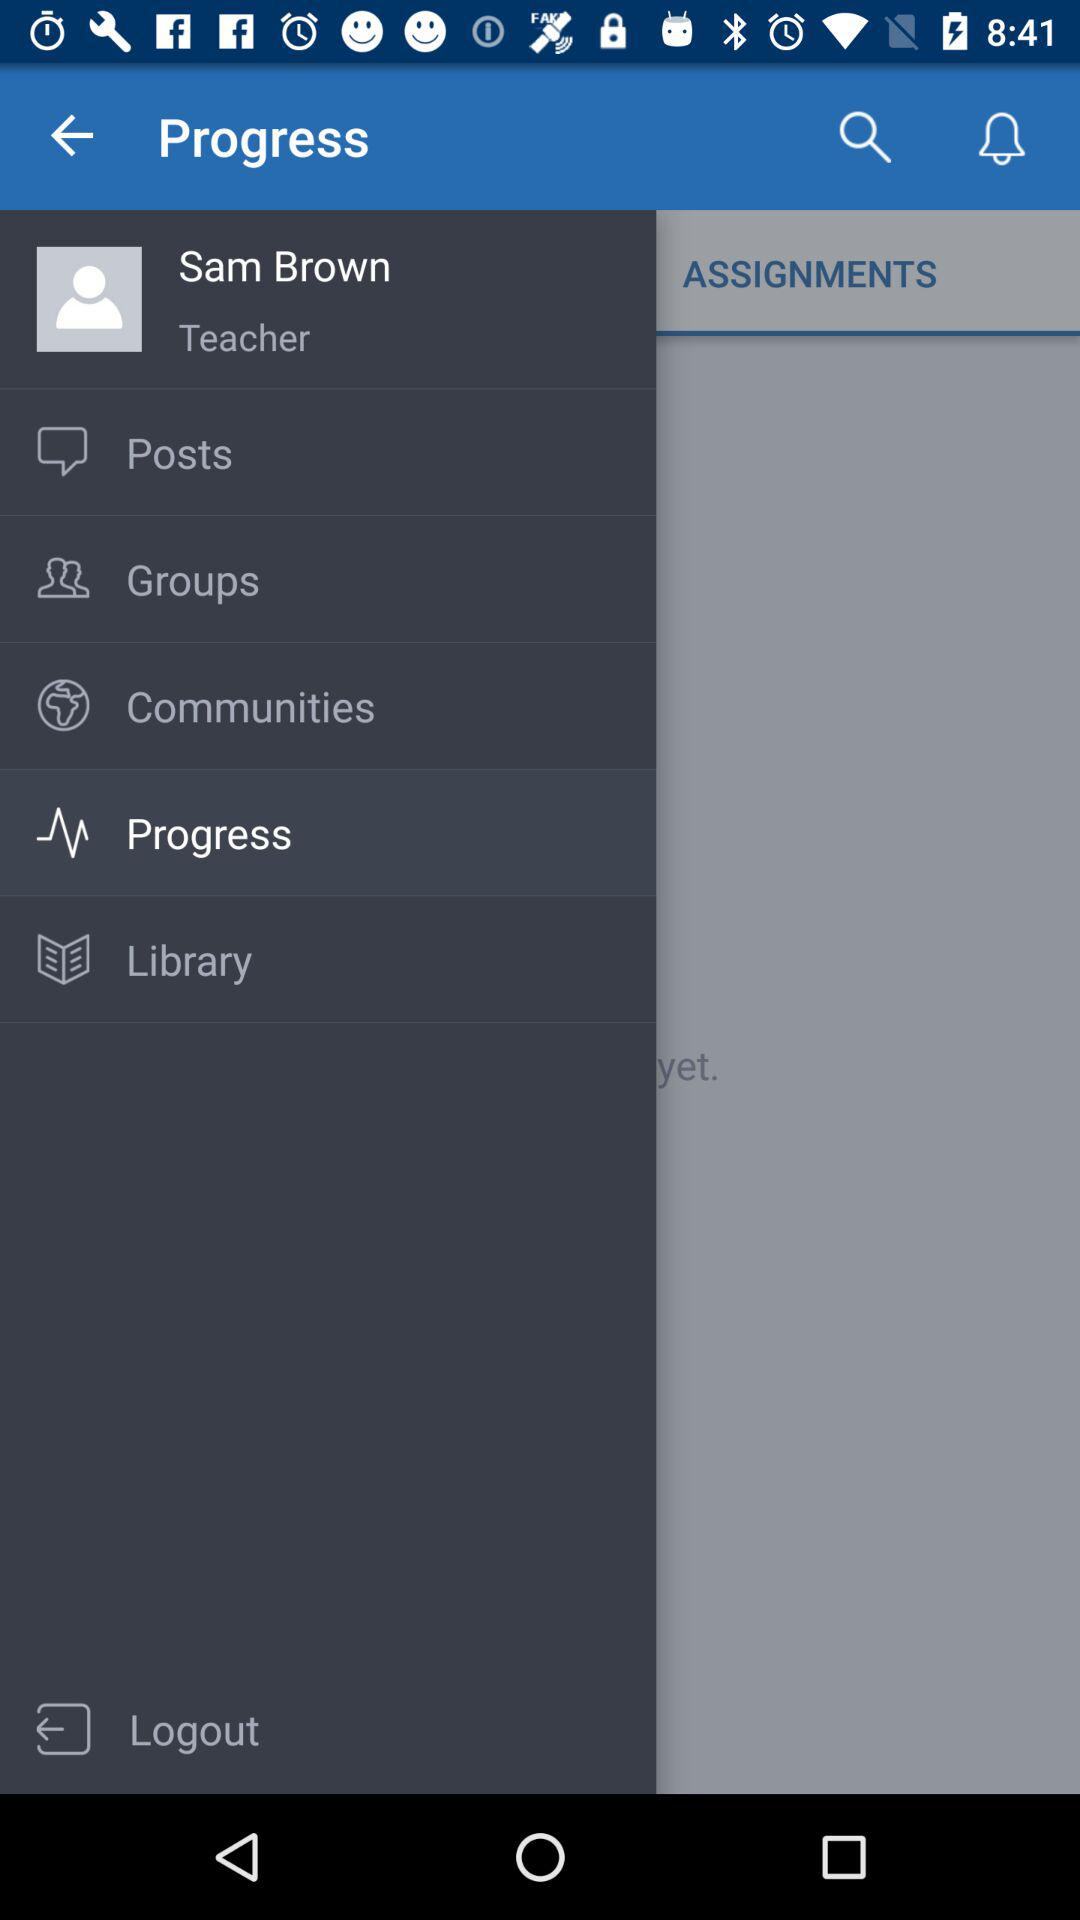What is the occupation of the user? The occupation of the user is "Teacher". 